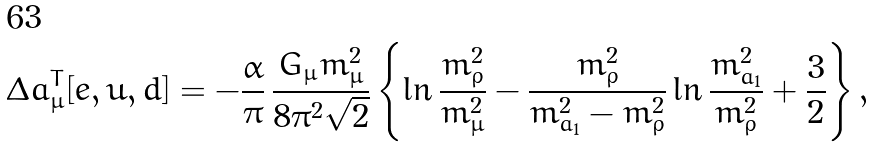Convert formula to latex. <formula><loc_0><loc_0><loc_500><loc_500>\Delta a _ { \mu } ^ { T } [ e , u , d ] = - \frac { \alpha } { \pi } \, \frac { G _ { \mu } m _ { \mu } ^ { 2 } } { 8 \pi ^ { 2 } \sqrt { 2 } } \left \{ \ln \frac { m _ { \rho } ^ { 2 } } { m _ { \mu } ^ { 2 } } - \frac { m _ { \rho } ^ { 2 } } { m _ { a _ { 1 } } ^ { 2 } - m _ { \rho } ^ { 2 } } \ln \frac { m _ { a _ { 1 } } ^ { 2 } } { m _ { \rho } ^ { 2 } } + \frac { 3 } { 2 } \right \} ,</formula> 